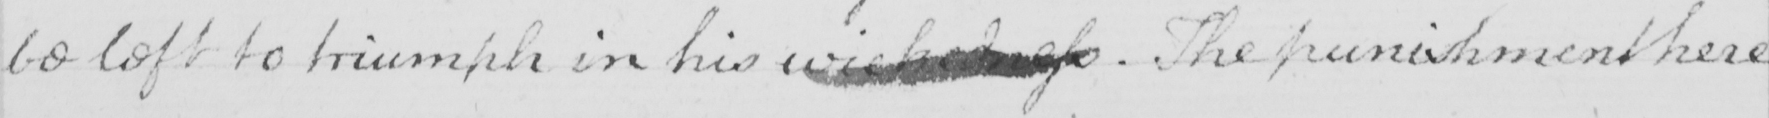What text is written in this handwritten line? be left to triumph in his wickedness  . The punishment here 